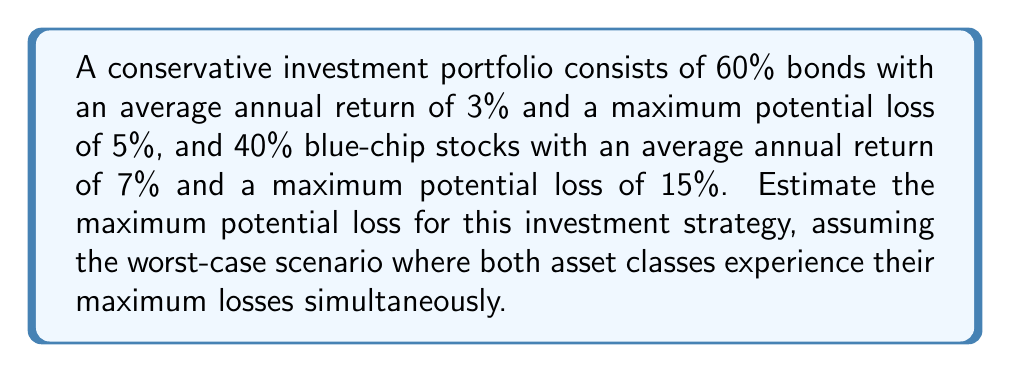Help me with this question. To estimate the maximum potential loss for this conservative investment strategy, we need to calculate the weighted average of the maximum potential losses for each asset class:

1. For bonds:
   - Allocation: 60%
   - Maximum potential loss: 5%
   - Contribution to total loss: $0.60 \times 5\% = 3\%$

2. For blue-chip stocks:
   - Allocation: 40%
   - Maximum potential loss: 15%
   - Contribution to total loss: $0.40 \times 15\% = 6\%$

3. Calculate the total maximum potential loss:
   $$\text{Total Loss} = \text{Bond Loss} + \text{Stock Loss}$$
   $$\text{Total Loss} = 3\% + 6\% = 9\%$$

Therefore, in the worst-case scenario where both asset classes experience their maximum losses simultaneously, the conservative investment strategy would have a maximum potential loss of 9%.
Answer: 9% 